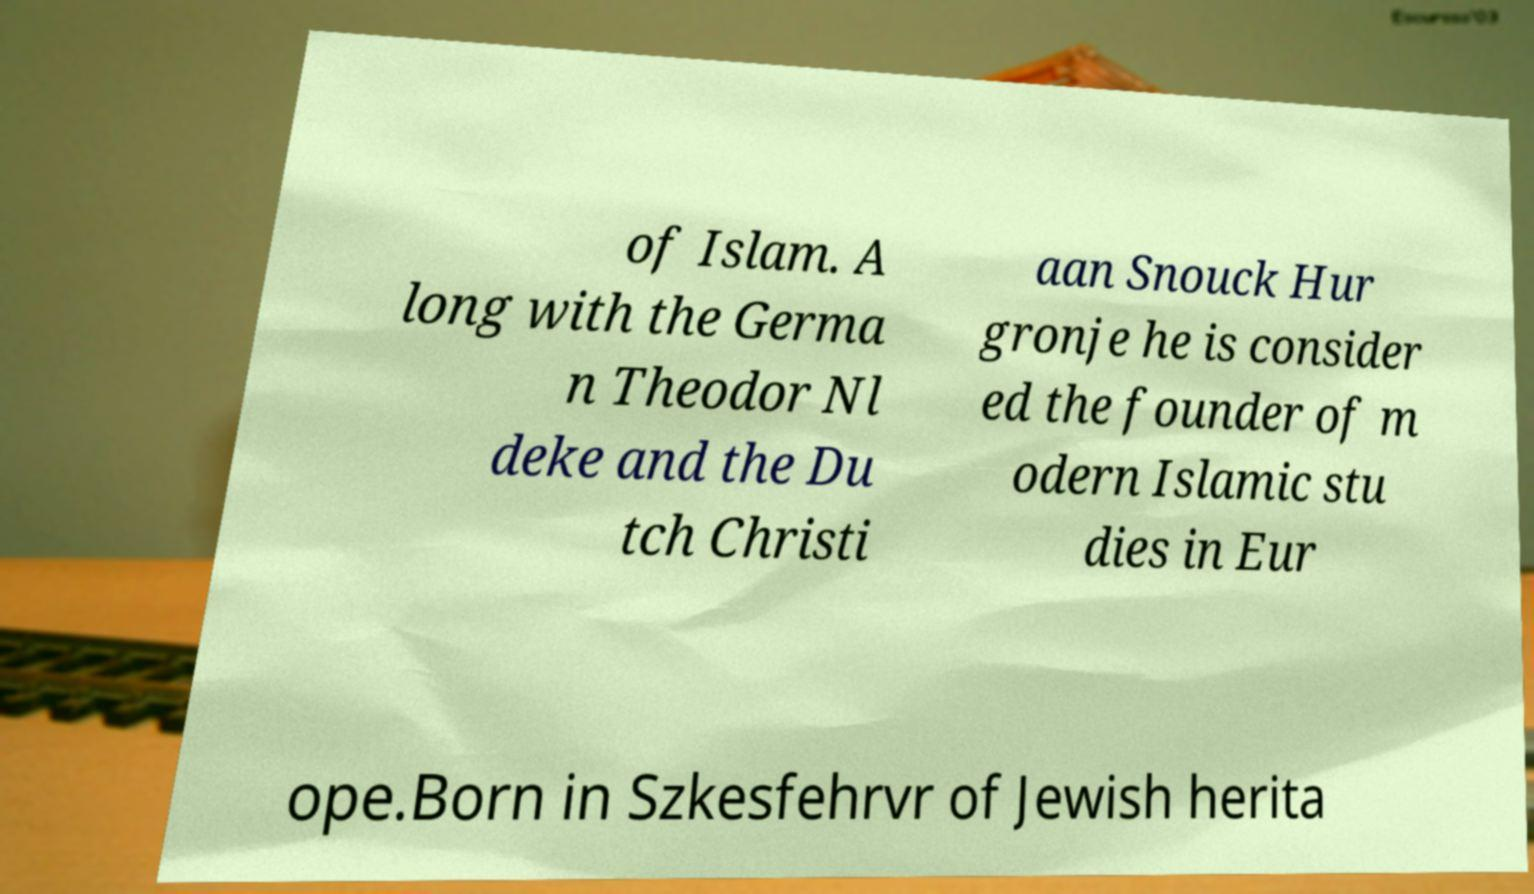What messages or text are displayed in this image? I need them in a readable, typed format. of Islam. A long with the Germa n Theodor Nl deke and the Du tch Christi aan Snouck Hur gronje he is consider ed the founder of m odern Islamic stu dies in Eur ope.Born in Szkesfehrvr of Jewish herita 